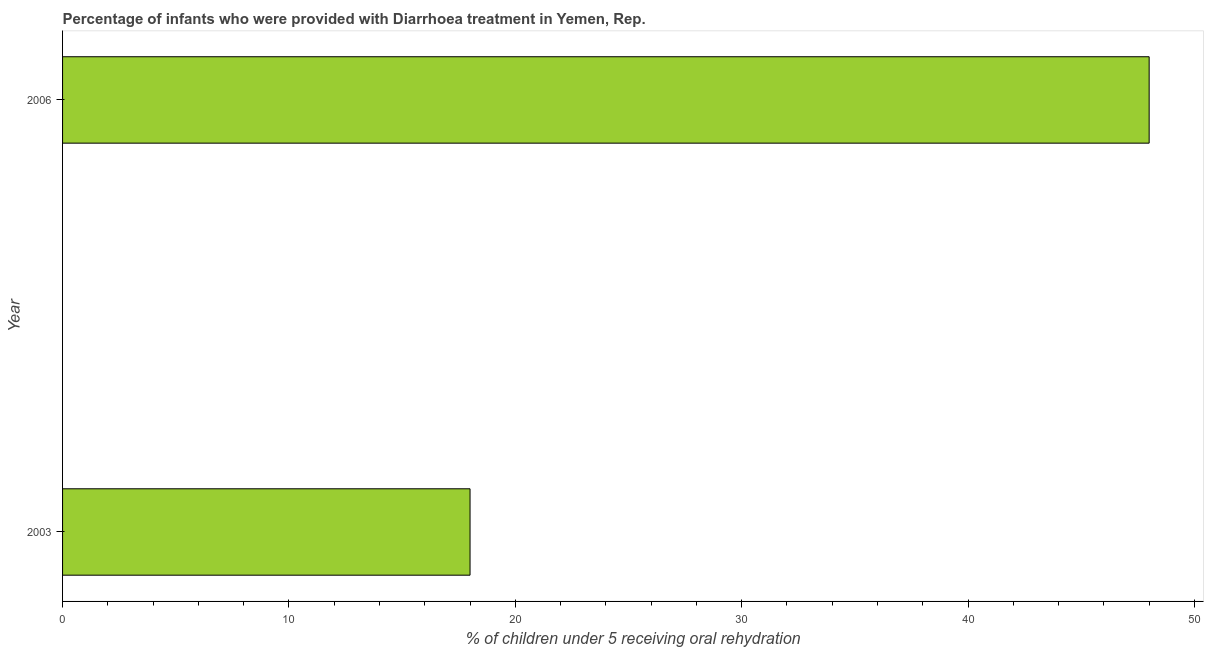Does the graph contain any zero values?
Offer a very short reply. No. What is the title of the graph?
Your answer should be compact. Percentage of infants who were provided with Diarrhoea treatment in Yemen, Rep. What is the label or title of the X-axis?
Offer a terse response. % of children under 5 receiving oral rehydration. What is the percentage of children who were provided with treatment diarrhoea in 2006?
Your answer should be compact. 48. Across all years, what is the maximum percentage of children who were provided with treatment diarrhoea?
Provide a succinct answer. 48. Across all years, what is the minimum percentage of children who were provided with treatment diarrhoea?
Give a very brief answer. 18. In which year was the percentage of children who were provided with treatment diarrhoea minimum?
Provide a short and direct response. 2003. What is the median percentage of children who were provided with treatment diarrhoea?
Your answer should be compact. 33. In how many years, is the percentage of children who were provided with treatment diarrhoea greater than 6 %?
Keep it short and to the point. 2. Do a majority of the years between 2003 and 2006 (inclusive) have percentage of children who were provided with treatment diarrhoea greater than 4 %?
Give a very brief answer. Yes. What is the ratio of the percentage of children who were provided with treatment diarrhoea in 2003 to that in 2006?
Offer a very short reply. 0.38. Is the percentage of children who were provided with treatment diarrhoea in 2003 less than that in 2006?
Your answer should be compact. Yes. How many bars are there?
Your response must be concise. 2. Are all the bars in the graph horizontal?
Your answer should be compact. Yes. How many years are there in the graph?
Provide a short and direct response. 2. Are the values on the major ticks of X-axis written in scientific E-notation?
Your answer should be very brief. No. What is the % of children under 5 receiving oral rehydration of 2003?
Offer a terse response. 18. What is the % of children under 5 receiving oral rehydration in 2006?
Provide a succinct answer. 48. 